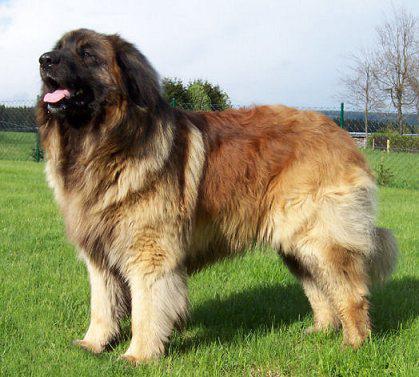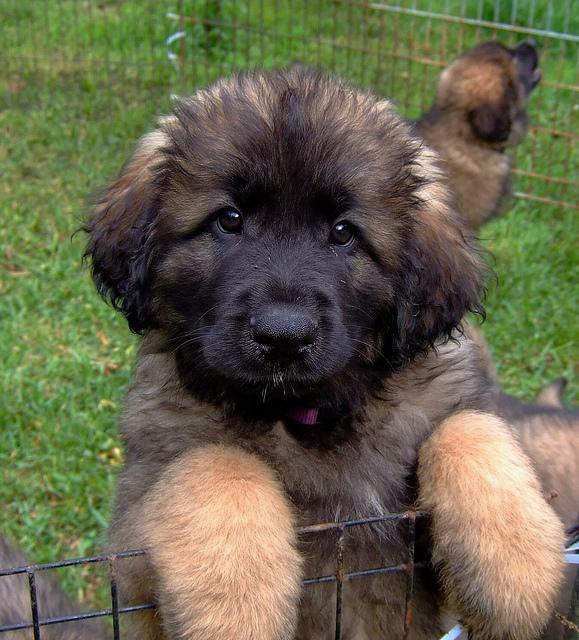The first image is the image on the left, the second image is the image on the right. Examine the images to the left and right. Is the description "A human is standing next to a large dog." accurate? Answer yes or no. No. The first image is the image on the left, the second image is the image on the right. Assess this claim about the two images: "There are people touching or petting a big dog with a black nose.". Correct or not? Answer yes or no. No. 